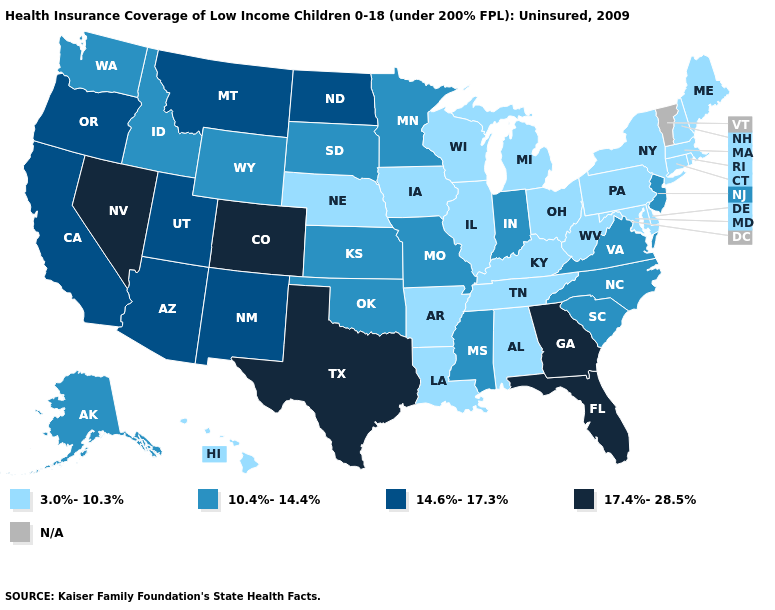What is the value of Missouri?
Short answer required. 10.4%-14.4%. What is the value of Tennessee?
Write a very short answer. 3.0%-10.3%. Name the states that have a value in the range 10.4%-14.4%?
Write a very short answer. Alaska, Idaho, Indiana, Kansas, Minnesota, Mississippi, Missouri, New Jersey, North Carolina, Oklahoma, South Carolina, South Dakota, Virginia, Washington, Wyoming. Among the states that border Tennessee , does Georgia have the highest value?
Keep it brief. Yes. What is the highest value in states that border New Mexico?
Be succinct. 17.4%-28.5%. Which states have the lowest value in the MidWest?
Short answer required. Illinois, Iowa, Michigan, Nebraska, Ohio, Wisconsin. Name the states that have a value in the range 14.6%-17.3%?
Be succinct. Arizona, California, Montana, New Mexico, North Dakota, Oregon, Utah. What is the lowest value in states that border New Jersey?
Quick response, please. 3.0%-10.3%. What is the highest value in the USA?
Keep it brief. 17.4%-28.5%. What is the highest value in the West ?
Quick response, please. 17.4%-28.5%. What is the value of New Hampshire?
Give a very brief answer. 3.0%-10.3%. Among the states that border Washington , does Oregon have the highest value?
Short answer required. Yes. Name the states that have a value in the range 17.4%-28.5%?
Give a very brief answer. Colorado, Florida, Georgia, Nevada, Texas. Name the states that have a value in the range 17.4%-28.5%?
Quick response, please. Colorado, Florida, Georgia, Nevada, Texas. What is the value of Florida?
Short answer required. 17.4%-28.5%. 